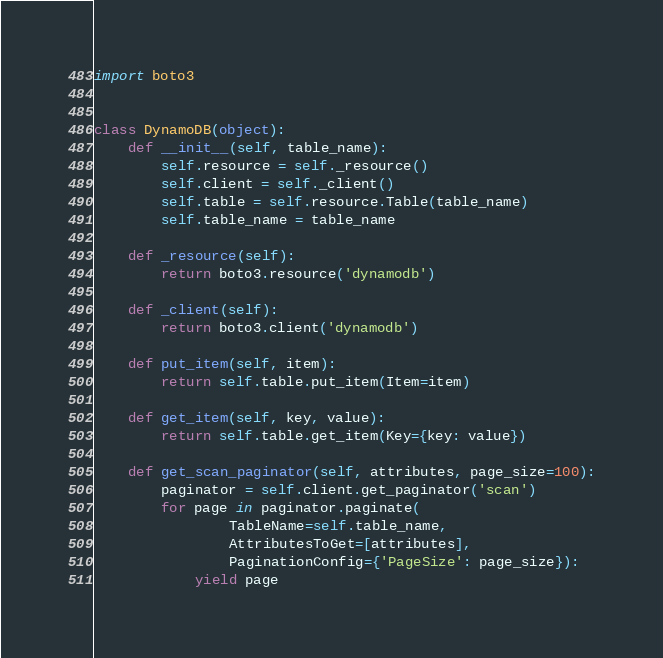Convert code to text. <code><loc_0><loc_0><loc_500><loc_500><_Python_>import boto3


class DynamoDB(object):
    def __init__(self, table_name):
        self.resource = self._resource()
        self.client = self._client()
        self.table = self.resource.Table(table_name)
        self.table_name = table_name

    def _resource(self):
        return boto3.resource('dynamodb')

    def _client(self):
        return boto3.client('dynamodb')

    def put_item(self, item):
        return self.table.put_item(Item=item)

    def get_item(self, key, value):
        return self.table.get_item(Key={key: value})

    def get_scan_paginator(self, attributes, page_size=100):
        paginator = self.client.get_paginator('scan')
        for page in paginator.paginate(
                TableName=self.table_name,
                AttributesToGet=[attributes],
                PaginationConfig={'PageSize': page_size}):
            yield page
</code> 